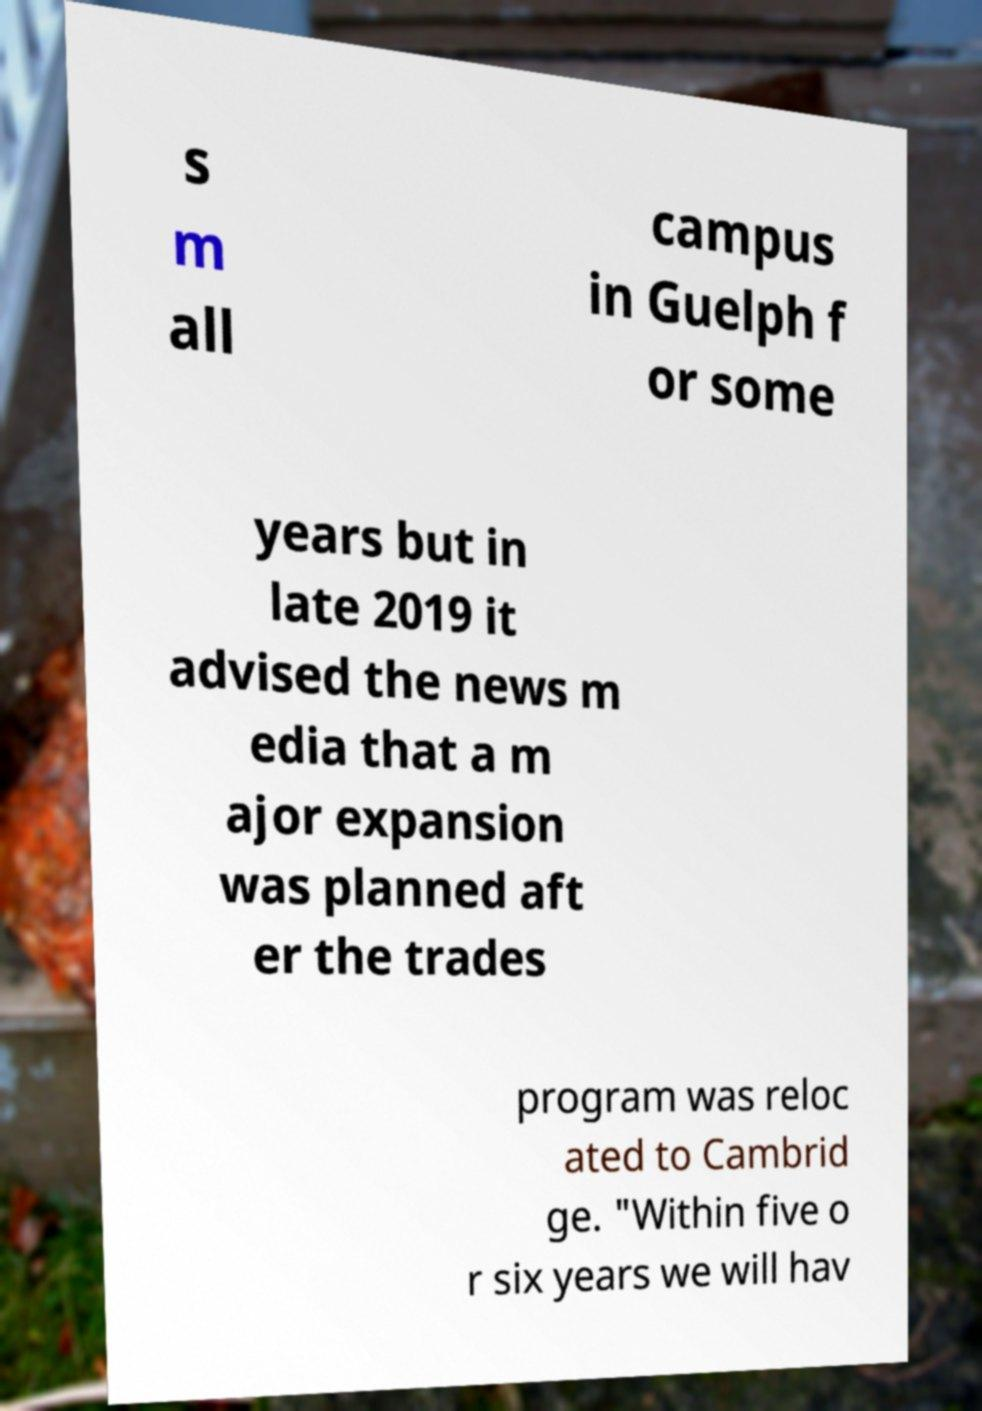Please identify and transcribe the text found in this image. s m all campus in Guelph f or some years but in late 2019 it advised the news m edia that a m ajor expansion was planned aft er the trades program was reloc ated to Cambrid ge. "Within five o r six years we will hav 